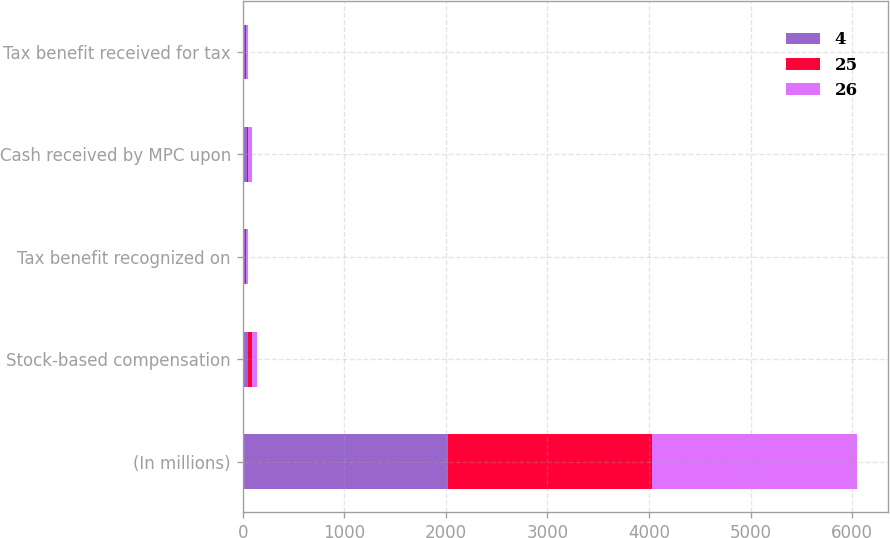Convert chart to OTSL. <chart><loc_0><loc_0><loc_500><loc_500><stacked_bar_chart><ecel><fcel>(In millions)<fcel>Stock-based compensation<fcel>Tax benefit recognized on<fcel>Cash received by MPC upon<fcel>Tax benefit received for tax<nl><fcel>4<fcel>2017<fcel>51<fcel>19<fcel>46<fcel>25<nl><fcel>25<fcel>2016<fcel>45<fcel>17<fcel>10<fcel>4<nl><fcel>26<fcel>2015<fcel>42<fcel>16<fcel>33<fcel>26<nl></chart> 